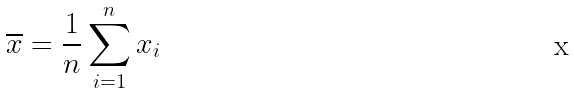Convert formula to latex. <formula><loc_0><loc_0><loc_500><loc_500>\overline { x } = \frac { 1 } { n } \sum _ { i = 1 } ^ { n } x _ { i }</formula> 